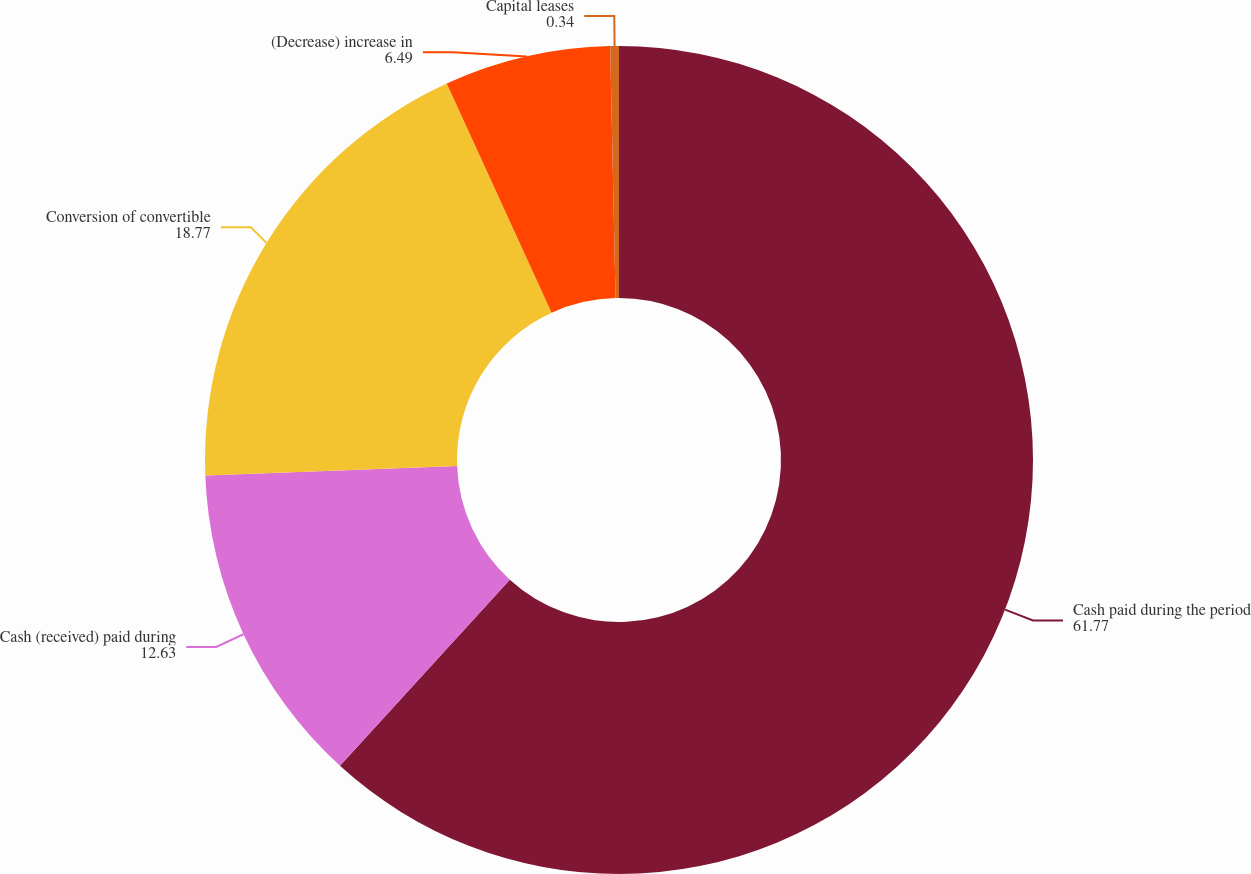<chart> <loc_0><loc_0><loc_500><loc_500><pie_chart><fcel>Cash paid during the period<fcel>Cash (received) paid during<fcel>Conversion of convertible<fcel>(Decrease) increase in<fcel>Capital leases<nl><fcel>61.77%<fcel>12.63%<fcel>18.77%<fcel>6.49%<fcel>0.34%<nl></chart> 